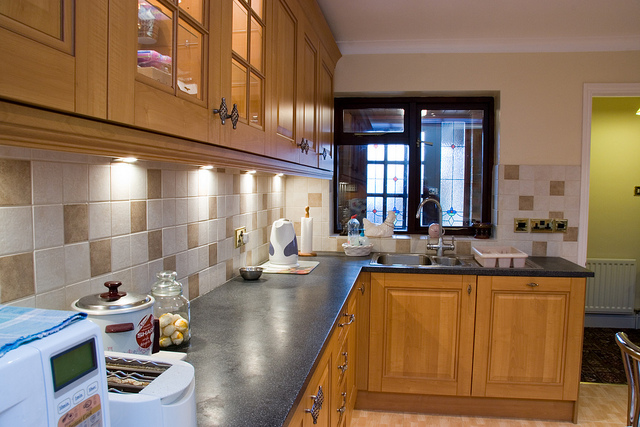Which features in this kitchen suggest it is designed for practical use? The features that point to practical use include ample countertop space for meal preparation, easily accessible cabinets for storage, and the presence of multiple appliances like the microwave and oven. The layout appears to prioritize function, facilitating cooking and movement within the space. 